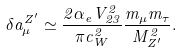<formula> <loc_0><loc_0><loc_500><loc_500>\delta a _ { \mu } ^ { Z ^ { \prime } } \simeq \frac { 2 \alpha _ { e } V _ { 2 3 } ^ { 2 } } { \pi c _ { W } ^ { 2 } } \frac { m _ { \mu } m _ { \tau } } { M _ { Z ^ { \prime } } ^ { 2 } } .</formula> 